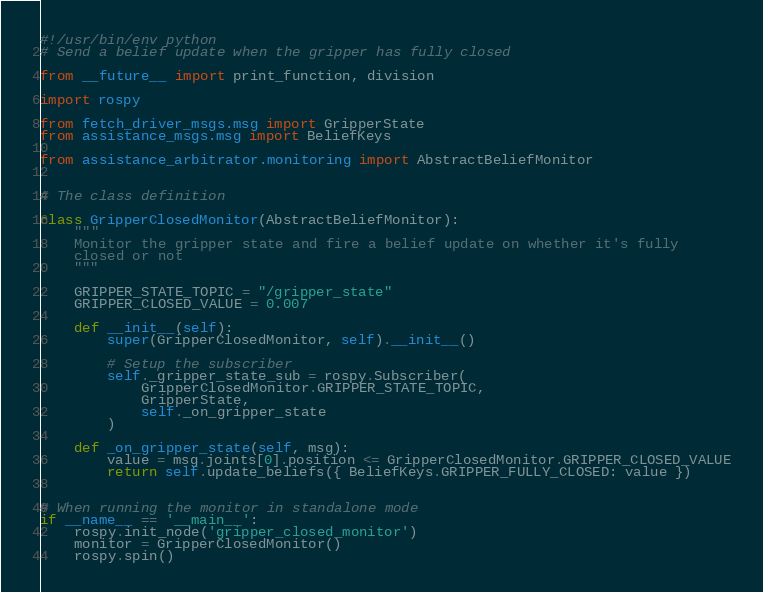<code> <loc_0><loc_0><loc_500><loc_500><_Python_>#!/usr/bin/env python
# Send a belief update when the gripper has fully closed

from __future__ import print_function, division

import rospy

from fetch_driver_msgs.msg import GripperState
from assistance_msgs.msg import BeliefKeys

from assistance_arbitrator.monitoring import AbstractBeliefMonitor


# The class definition

class GripperClosedMonitor(AbstractBeliefMonitor):
    """
    Monitor the gripper state and fire a belief update on whether it's fully
    closed or not
    """

    GRIPPER_STATE_TOPIC = "/gripper_state"
    GRIPPER_CLOSED_VALUE = 0.007

    def __init__(self):
        super(GripperClosedMonitor, self).__init__()

        # Setup the subscriber
        self._gripper_state_sub = rospy.Subscriber(
            GripperClosedMonitor.GRIPPER_STATE_TOPIC,
            GripperState,
            self._on_gripper_state
        )

    def _on_gripper_state(self, msg):
        value = msg.joints[0].position <= GripperClosedMonitor.GRIPPER_CLOSED_VALUE
        return self.update_beliefs({ BeliefKeys.GRIPPER_FULLY_CLOSED: value })


# When running the monitor in standalone mode
if __name__ == '__main__':
    rospy.init_node('gripper_closed_monitor')
    monitor = GripperClosedMonitor()
    rospy.spin()
</code> 